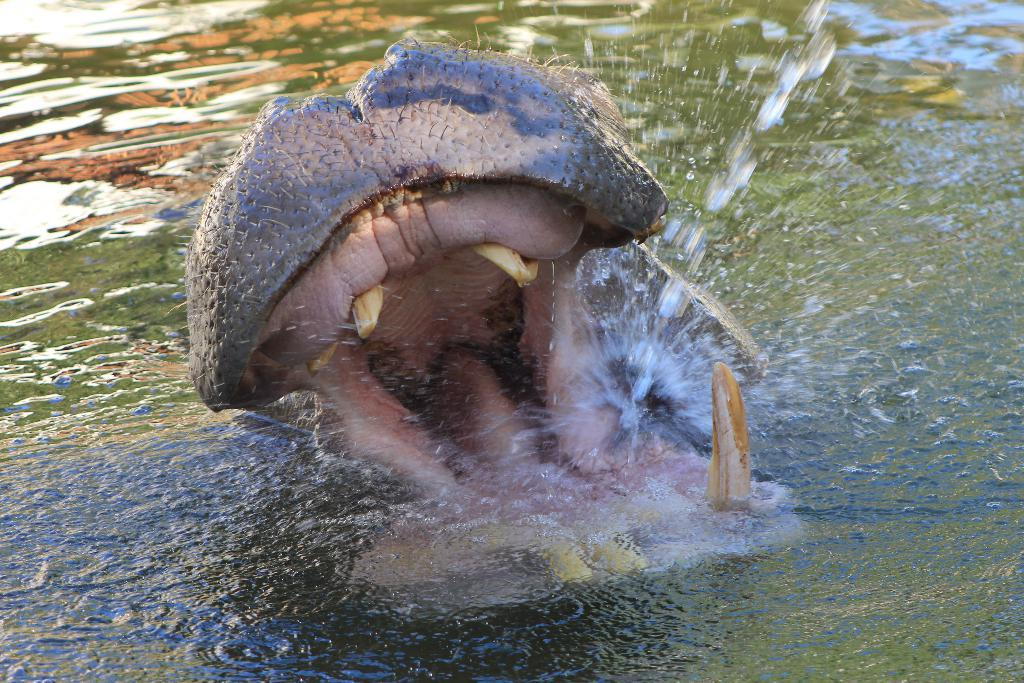What animal is the main subject of the image? There is a hippopotamus in the image. What is the hippopotamus doing in the image? The hippopotamus is opening its mouth. Where is the hippopotamus located in the image? The hippopotamus is in the water. What type of skin can be seen on the calendar in the image? There is no calendar present in the image, and therefore no skin can be observed on it. 